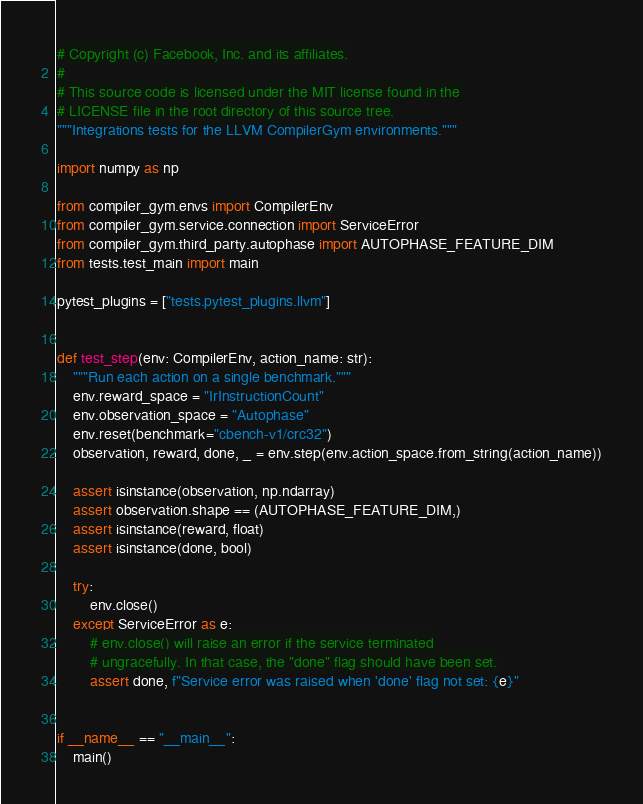<code> <loc_0><loc_0><loc_500><loc_500><_Python_># Copyright (c) Facebook, Inc. and its affiliates.
#
# This source code is licensed under the MIT license found in the
# LICENSE file in the root directory of this source tree.
"""Integrations tests for the LLVM CompilerGym environments."""

import numpy as np

from compiler_gym.envs import CompilerEnv
from compiler_gym.service.connection import ServiceError
from compiler_gym.third_party.autophase import AUTOPHASE_FEATURE_DIM
from tests.test_main import main

pytest_plugins = ["tests.pytest_plugins.llvm"]


def test_step(env: CompilerEnv, action_name: str):
    """Run each action on a single benchmark."""
    env.reward_space = "IrInstructionCount"
    env.observation_space = "Autophase"
    env.reset(benchmark="cbench-v1/crc32")
    observation, reward, done, _ = env.step(env.action_space.from_string(action_name))

    assert isinstance(observation, np.ndarray)
    assert observation.shape == (AUTOPHASE_FEATURE_DIM,)
    assert isinstance(reward, float)
    assert isinstance(done, bool)

    try:
        env.close()
    except ServiceError as e:
        # env.close() will raise an error if the service terminated
        # ungracefully. In that case, the "done" flag should have been set.
        assert done, f"Service error was raised when 'done' flag not set: {e}"


if __name__ == "__main__":
    main()
</code> 